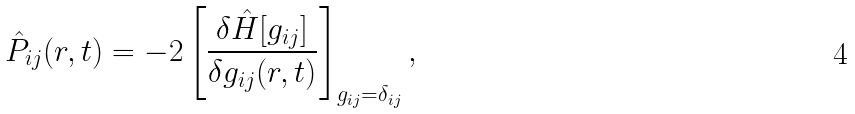<formula> <loc_0><loc_0><loc_500><loc_500>\hat { P } _ { i j } ( { r } , t ) = - 2 \left [ \frac { \delta { \hat { H } } [ g _ { i j } ] } { \delta g _ { i j } ( { r } , t ) } \right ] _ { g _ { i j } = \delta _ { i j } } ,</formula> 